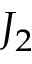<formula> <loc_0><loc_0><loc_500><loc_500>J _ { 2 }</formula> 